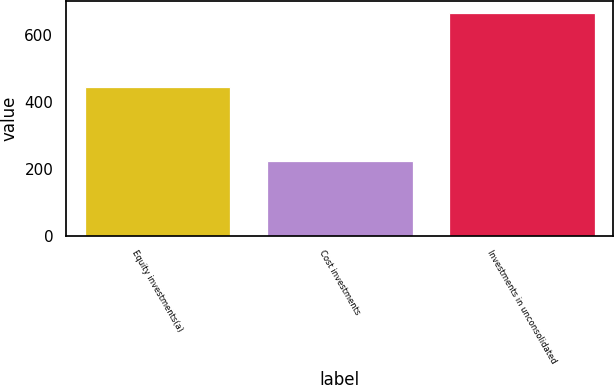<chart> <loc_0><loc_0><loc_500><loc_500><bar_chart><fcel>Equity investments(a)<fcel>Cost investments<fcel>Investments in unconsolidated<nl><fcel>443<fcel>224<fcel>667<nl></chart> 